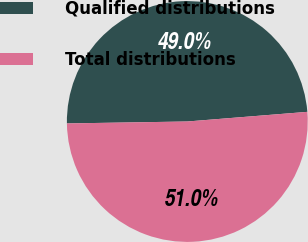<chart> <loc_0><loc_0><loc_500><loc_500><pie_chart><fcel>Qualified distributions<fcel>Total distributions<nl><fcel>48.98%<fcel>51.02%<nl></chart> 